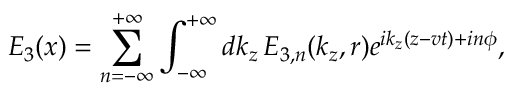Convert formula to latex. <formula><loc_0><loc_0><loc_500><loc_500>E _ { 3 } ( x ) = \sum _ { n = - \infty } ^ { + \infty } \int _ { - \infty } ^ { + \infty } d k _ { z } \, E _ { 3 , n } ( k _ { z } , r ) e ^ { i k _ { z } ( z - v t ) + i n \phi } ,</formula> 